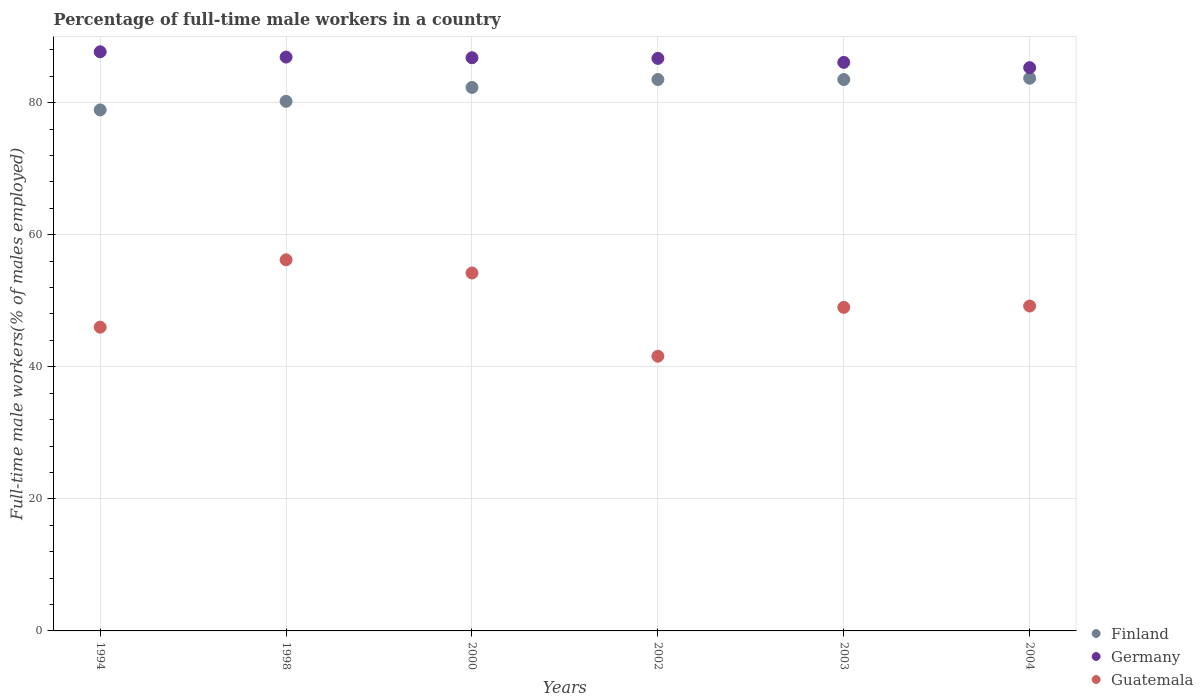How many different coloured dotlines are there?
Give a very brief answer. 3. Across all years, what is the maximum percentage of full-time male workers in Finland?
Provide a succinct answer. 83.7. Across all years, what is the minimum percentage of full-time male workers in Finland?
Offer a terse response. 78.9. In which year was the percentage of full-time male workers in Germany maximum?
Offer a terse response. 1994. In which year was the percentage of full-time male workers in Guatemala minimum?
Offer a very short reply. 2002. What is the total percentage of full-time male workers in Finland in the graph?
Make the answer very short. 492.1. What is the difference between the percentage of full-time male workers in Finland in 2003 and that in 2004?
Keep it short and to the point. -0.2. What is the difference between the percentage of full-time male workers in Finland in 2004 and the percentage of full-time male workers in Guatemala in 2000?
Offer a very short reply. 29.5. What is the average percentage of full-time male workers in Finland per year?
Provide a short and direct response. 82.02. In the year 2002, what is the difference between the percentage of full-time male workers in Guatemala and percentage of full-time male workers in Finland?
Provide a succinct answer. -41.9. What is the ratio of the percentage of full-time male workers in Guatemala in 1998 to that in 2002?
Offer a terse response. 1.35. What is the difference between the highest and the lowest percentage of full-time male workers in Germany?
Your answer should be compact. 2.4. Is it the case that in every year, the sum of the percentage of full-time male workers in Finland and percentage of full-time male workers in Guatemala  is greater than the percentage of full-time male workers in Germany?
Your answer should be compact. Yes. Does the percentage of full-time male workers in Finland monotonically increase over the years?
Provide a succinct answer. No. Is the percentage of full-time male workers in Guatemala strictly greater than the percentage of full-time male workers in Germany over the years?
Your answer should be compact. No. Is the percentage of full-time male workers in Finland strictly less than the percentage of full-time male workers in Germany over the years?
Offer a terse response. Yes. How many dotlines are there?
Make the answer very short. 3. How many years are there in the graph?
Your response must be concise. 6. Are the values on the major ticks of Y-axis written in scientific E-notation?
Offer a terse response. No. Where does the legend appear in the graph?
Give a very brief answer. Bottom right. How many legend labels are there?
Offer a very short reply. 3. How are the legend labels stacked?
Your answer should be compact. Vertical. What is the title of the graph?
Offer a terse response. Percentage of full-time male workers in a country. What is the label or title of the X-axis?
Your answer should be compact. Years. What is the label or title of the Y-axis?
Ensure brevity in your answer.  Full-time male workers(% of males employed). What is the Full-time male workers(% of males employed) in Finland in 1994?
Ensure brevity in your answer.  78.9. What is the Full-time male workers(% of males employed) in Germany in 1994?
Make the answer very short. 87.7. What is the Full-time male workers(% of males employed) in Finland in 1998?
Make the answer very short. 80.2. What is the Full-time male workers(% of males employed) in Germany in 1998?
Offer a terse response. 86.9. What is the Full-time male workers(% of males employed) of Guatemala in 1998?
Provide a short and direct response. 56.2. What is the Full-time male workers(% of males employed) in Finland in 2000?
Provide a succinct answer. 82.3. What is the Full-time male workers(% of males employed) in Germany in 2000?
Offer a terse response. 86.8. What is the Full-time male workers(% of males employed) in Guatemala in 2000?
Offer a very short reply. 54.2. What is the Full-time male workers(% of males employed) of Finland in 2002?
Your response must be concise. 83.5. What is the Full-time male workers(% of males employed) of Germany in 2002?
Make the answer very short. 86.7. What is the Full-time male workers(% of males employed) in Guatemala in 2002?
Offer a terse response. 41.6. What is the Full-time male workers(% of males employed) of Finland in 2003?
Offer a terse response. 83.5. What is the Full-time male workers(% of males employed) of Germany in 2003?
Offer a terse response. 86.1. What is the Full-time male workers(% of males employed) of Finland in 2004?
Provide a succinct answer. 83.7. What is the Full-time male workers(% of males employed) in Germany in 2004?
Your response must be concise. 85.3. What is the Full-time male workers(% of males employed) of Guatemala in 2004?
Offer a very short reply. 49.2. Across all years, what is the maximum Full-time male workers(% of males employed) in Finland?
Provide a succinct answer. 83.7. Across all years, what is the maximum Full-time male workers(% of males employed) in Germany?
Provide a succinct answer. 87.7. Across all years, what is the maximum Full-time male workers(% of males employed) in Guatemala?
Your answer should be very brief. 56.2. Across all years, what is the minimum Full-time male workers(% of males employed) in Finland?
Offer a very short reply. 78.9. Across all years, what is the minimum Full-time male workers(% of males employed) in Germany?
Make the answer very short. 85.3. Across all years, what is the minimum Full-time male workers(% of males employed) in Guatemala?
Make the answer very short. 41.6. What is the total Full-time male workers(% of males employed) of Finland in the graph?
Offer a very short reply. 492.1. What is the total Full-time male workers(% of males employed) of Germany in the graph?
Make the answer very short. 519.5. What is the total Full-time male workers(% of males employed) in Guatemala in the graph?
Provide a short and direct response. 296.2. What is the difference between the Full-time male workers(% of males employed) in Germany in 1994 and that in 2000?
Keep it short and to the point. 0.9. What is the difference between the Full-time male workers(% of males employed) in Germany in 1994 and that in 2002?
Your response must be concise. 1. What is the difference between the Full-time male workers(% of males employed) in Finland in 1994 and that in 2003?
Ensure brevity in your answer.  -4.6. What is the difference between the Full-time male workers(% of males employed) of Germany in 1994 and that in 2003?
Give a very brief answer. 1.6. What is the difference between the Full-time male workers(% of males employed) in Germany in 1994 and that in 2004?
Your answer should be compact. 2.4. What is the difference between the Full-time male workers(% of males employed) in Guatemala in 1994 and that in 2004?
Provide a short and direct response. -3.2. What is the difference between the Full-time male workers(% of males employed) in Finland in 1998 and that in 2000?
Keep it short and to the point. -2.1. What is the difference between the Full-time male workers(% of males employed) of Guatemala in 1998 and that in 2000?
Your response must be concise. 2. What is the difference between the Full-time male workers(% of males employed) in Finland in 1998 and that in 2002?
Your answer should be compact. -3.3. What is the difference between the Full-time male workers(% of males employed) of Germany in 1998 and that in 2002?
Give a very brief answer. 0.2. What is the difference between the Full-time male workers(% of males employed) in Finland in 1998 and that in 2003?
Make the answer very short. -3.3. What is the difference between the Full-time male workers(% of males employed) in Germany in 1998 and that in 2003?
Your response must be concise. 0.8. What is the difference between the Full-time male workers(% of males employed) of Guatemala in 1998 and that in 2003?
Your response must be concise. 7.2. What is the difference between the Full-time male workers(% of males employed) in Finland in 1998 and that in 2004?
Ensure brevity in your answer.  -3.5. What is the difference between the Full-time male workers(% of males employed) in Germany in 1998 and that in 2004?
Give a very brief answer. 1.6. What is the difference between the Full-time male workers(% of males employed) in Finland in 2000 and that in 2002?
Your response must be concise. -1.2. What is the difference between the Full-time male workers(% of males employed) of Finland in 2000 and that in 2003?
Ensure brevity in your answer.  -1.2. What is the difference between the Full-time male workers(% of males employed) of Guatemala in 2000 and that in 2003?
Offer a terse response. 5.2. What is the difference between the Full-time male workers(% of males employed) in Germany in 2000 and that in 2004?
Provide a succinct answer. 1.5. What is the difference between the Full-time male workers(% of males employed) of Germany in 2002 and that in 2004?
Your answer should be compact. 1.4. What is the difference between the Full-time male workers(% of males employed) in Guatemala in 2002 and that in 2004?
Ensure brevity in your answer.  -7.6. What is the difference between the Full-time male workers(% of males employed) of Germany in 2003 and that in 2004?
Provide a short and direct response. 0.8. What is the difference between the Full-time male workers(% of males employed) of Guatemala in 2003 and that in 2004?
Make the answer very short. -0.2. What is the difference between the Full-time male workers(% of males employed) in Finland in 1994 and the Full-time male workers(% of males employed) in Guatemala in 1998?
Ensure brevity in your answer.  22.7. What is the difference between the Full-time male workers(% of males employed) of Germany in 1994 and the Full-time male workers(% of males employed) of Guatemala in 1998?
Give a very brief answer. 31.5. What is the difference between the Full-time male workers(% of males employed) of Finland in 1994 and the Full-time male workers(% of males employed) of Germany in 2000?
Your answer should be compact. -7.9. What is the difference between the Full-time male workers(% of males employed) of Finland in 1994 and the Full-time male workers(% of males employed) of Guatemala in 2000?
Provide a short and direct response. 24.7. What is the difference between the Full-time male workers(% of males employed) in Germany in 1994 and the Full-time male workers(% of males employed) in Guatemala in 2000?
Provide a succinct answer. 33.5. What is the difference between the Full-time male workers(% of males employed) of Finland in 1994 and the Full-time male workers(% of males employed) of Germany in 2002?
Your answer should be very brief. -7.8. What is the difference between the Full-time male workers(% of males employed) of Finland in 1994 and the Full-time male workers(% of males employed) of Guatemala in 2002?
Ensure brevity in your answer.  37.3. What is the difference between the Full-time male workers(% of males employed) in Germany in 1994 and the Full-time male workers(% of males employed) in Guatemala in 2002?
Keep it short and to the point. 46.1. What is the difference between the Full-time male workers(% of males employed) in Finland in 1994 and the Full-time male workers(% of males employed) in Guatemala in 2003?
Your answer should be compact. 29.9. What is the difference between the Full-time male workers(% of males employed) of Germany in 1994 and the Full-time male workers(% of males employed) of Guatemala in 2003?
Provide a short and direct response. 38.7. What is the difference between the Full-time male workers(% of males employed) of Finland in 1994 and the Full-time male workers(% of males employed) of Germany in 2004?
Ensure brevity in your answer.  -6.4. What is the difference between the Full-time male workers(% of males employed) of Finland in 1994 and the Full-time male workers(% of males employed) of Guatemala in 2004?
Give a very brief answer. 29.7. What is the difference between the Full-time male workers(% of males employed) of Germany in 1994 and the Full-time male workers(% of males employed) of Guatemala in 2004?
Give a very brief answer. 38.5. What is the difference between the Full-time male workers(% of males employed) of Finland in 1998 and the Full-time male workers(% of males employed) of Germany in 2000?
Your answer should be compact. -6.6. What is the difference between the Full-time male workers(% of males employed) in Finland in 1998 and the Full-time male workers(% of males employed) in Guatemala in 2000?
Make the answer very short. 26. What is the difference between the Full-time male workers(% of males employed) in Germany in 1998 and the Full-time male workers(% of males employed) in Guatemala in 2000?
Offer a terse response. 32.7. What is the difference between the Full-time male workers(% of males employed) in Finland in 1998 and the Full-time male workers(% of males employed) in Guatemala in 2002?
Give a very brief answer. 38.6. What is the difference between the Full-time male workers(% of males employed) of Germany in 1998 and the Full-time male workers(% of males employed) of Guatemala in 2002?
Keep it short and to the point. 45.3. What is the difference between the Full-time male workers(% of males employed) in Finland in 1998 and the Full-time male workers(% of males employed) in Germany in 2003?
Your answer should be very brief. -5.9. What is the difference between the Full-time male workers(% of males employed) of Finland in 1998 and the Full-time male workers(% of males employed) of Guatemala in 2003?
Your answer should be compact. 31.2. What is the difference between the Full-time male workers(% of males employed) in Germany in 1998 and the Full-time male workers(% of males employed) in Guatemala in 2003?
Your answer should be very brief. 37.9. What is the difference between the Full-time male workers(% of males employed) of Finland in 1998 and the Full-time male workers(% of males employed) of Germany in 2004?
Provide a succinct answer. -5.1. What is the difference between the Full-time male workers(% of males employed) in Finland in 1998 and the Full-time male workers(% of males employed) in Guatemala in 2004?
Offer a very short reply. 31. What is the difference between the Full-time male workers(% of males employed) of Germany in 1998 and the Full-time male workers(% of males employed) of Guatemala in 2004?
Offer a terse response. 37.7. What is the difference between the Full-time male workers(% of males employed) in Finland in 2000 and the Full-time male workers(% of males employed) in Germany in 2002?
Offer a terse response. -4.4. What is the difference between the Full-time male workers(% of males employed) in Finland in 2000 and the Full-time male workers(% of males employed) in Guatemala in 2002?
Keep it short and to the point. 40.7. What is the difference between the Full-time male workers(% of males employed) in Germany in 2000 and the Full-time male workers(% of males employed) in Guatemala in 2002?
Keep it short and to the point. 45.2. What is the difference between the Full-time male workers(% of males employed) in Finland in 2000 and the Full-time male workers(% of males employed) in Guatemala in 2003?
Provide a succinct answer. 33.3. What is the difference between the Full-time male workers(% of males employed) in Germany in 2000 and the Full-time male workers(% of males employed) in Guatemala in 2003?
Make the answer very short. 37.8. What is the difference between the Full-time male workers(% of males employed) of Finland in 2000 and the Full-time male workers(% of males employed) of Germany in 2004?
Provide a short and direct response. -3. What is the difference between the Full-time male workers(% of males employed) of Finland in 2000 and the Full-time male workers(% of males employed) of Guatemala in 2004?
Your answer should be compact. 33.1. What is the difference between the Full-time male workers(% of males employed) in Germany in 2000 and the Full-time male workers(% of males employed) in Guatemala in 2004?
Provide a succinct answer. 37.6. What is the difference between the Full-time male workers(% of males employed) in Finland in 2002 and the Full-time male workers(% of males employed) in Guatemala in 2003?
Keep it short and to the point. 34.5. What is the difference between the Full-time male workers(% of males employed) in Germany in 2002 and the Full-time male workers(% of males employed) in Guatemala in 2003?
Ensure brevity in your answer.  37.7. What is the difference between the Full-time male workers(% of males employed) of Finland in 2002 and the Full-time male workers(% of males employed) of Germany in 2004?
Make the answer very short. -1.8. What is the difference between the Full-time male workers(% of males employed) in Finland in 2002 and the Full-time male workers(% of males employed) in Guatemala in 2004?
Your response must be concise. 34.3. What is the difference between the Full-time male workers(% of males employed) of Germany in 2002 and the Full-time male workers(% of males employed) of Guatemala in 2004?
Give a very brief answer. 37.5. What is the difference between the Full-time male workers(% of males employed) in Finland in 2003 and the Full-time male workers(% of males employed) in Germany in 2004?
Your answer should be very brief. -1.8. What is the difference between the Full-time male workers(% of males employed) in Finland in 2003 and the Full-time male workers(% of males employed) in Guatemala in 2004?
Your answer should be compact. 34.3. What is the difference between the Full-time male workers(% of males employed) of Germany in 2003 and the Full-time male workers(% of males employed) of Guatemala in 2004?
Provide a short and direct response. 36.9. What is the average Full-time male workers(% of males employed) of Finland per year?
Ensure brevity in your answer.  82.02. What is the average Full-time male workers(% of males employed) in Germany per year?
Keep it short and to the point. 86.58. What is the average Full-time male workers(% of males employed) in Guatemala per year?
Offer a very short reply. 49.37. In the year 1994, what is the difference between the Full-time male workers(% of males employed) of Finland and Full-time male workers(% of males employed) of Germany?
Give a very brief answer. -8.8. In the year 1994, what is the difference between the Full-time male workers(% of males employed) of Finland and Full-time male workers(% of males employed) of Guatemala?
Your answer should be very brief. 32.9. In the year 1994, what is the difference between the Full-time male workers(% of males employed) of Germany and Full-time male workers(% of males employed) of Guatemala?
Make the answer very short. 41.7. In the year 1998, what is the difference between the Full-time male workers(% of males employed) in Finland and Full-time male workers(% of males employed) in Germany?
Provide a succinct answer. -6.7. In the year 1998, what is the difference between the Full-time male workers(% of males employed) in Finland and Full-time male workers(% of males employed) in Guatemala?
Keep it short and to the point. 24. In the year 1998, what is the difference between the Full-time male workers(% of males employed) of Germany and Full-time male workers(% of males employed) of Guatemala?
Offer a very short reply. 30.7. In the year 2000, what is the difference between the Full-time male workers(% of males employed) of Finland and Full-time male workers(% of males employed) of Germany?
Ensure brevity in your answer.  -4.5. In the year 2000, what is the difference between the Full-time male workers(% of males employed) in Finland and Full-time male workers(% of males employed) in Guatemala?
Provide a short and direct response. 28.1. In the year 2000, what is the difference between the Full-time male workers(% of males employed) of Germany and Full-time male workers(% of males employed) of Guatemala?
Offer a terse response. 32.6. In the year 2002, what is the difference between the Full-time male workers(% of males employed) in Finland and Full-time male workers(% of males employed) in Guatemala?
Provide a short and direct response. 41.9. In the year 2002, what is the difference between the Full-time male workers(% of males employed) of Germany and Full-time male workers(% of males employed) of Guatemala?
Ensure brevity in your answer.  45.1. In the year 2003, what is the difference between the Full-time male workers(% of males employed) in Finland and Full-time male workers(% of males employed) in Germany?
Your answer should be compact. -2.6. In the year 2003, what is the difference between the Full-time male workers(% of males employed) in Finland and Full-time male workers(% of males employed) in Guatemala?
Your response must be concise. 34.5. In the year 2003, what is the difference between the Full-time male workers(% of males employed) in Germany and Full-time male workers(% of males employed) in Guatemala?
Make the answer very short. 37.1. In the year 2004, what is the difference between the Full-time male workers(% of males employed) in Finland and Full-time male workers(% of males employed) in Germany?
Your answer should be compact. -1.6. In the year 2004, what is the difference between the Full-time male workers(% of males employed) of Finland and Full-time male workers(% of males employed) of Guatemala?
Your response must be concise. 34.5. In the year 2004, what is the difference between the Full-time male workers(% of males employed) in Germany and Full-time male workers(% of males employed) in Guatemala?
Your answer should be compact. 36.1. What is the ratio of the Full-time male workers(% of males employed) in Finland in 1994 to that in 1998?
Provide a short and direct response. 0.98. What is the ratio of the Full-time male workers(% of males employed) in Germany in 1994 to that in 1998?
Your response must be concise. 1.01. What is the ratio of the Full-time male workers(% of males employed) in Guatemala in 1994 to that in 1998?
Offer a terse response. 0.82. What is the ratio of the Full-time male workers(% of males employed) of Finland in 1994 to that in 2000?
Offer a very short reply. 0.96. What is the ratio of the Full-time male workers(% of males employed) in Germany in 1994 to that in 2000?
Give a very brief answer. 1.01. What is the ratio of the Full-time male workers(% of males employed) of Guatemala in 1994 to that in 2000?
Offer a terse response. 0.85. What is the ratio of the Full-time male workers(% of males employed) in Finland in 1994 to that in 2002?
Offer a very short reply. 0.94. What is the ratio of the Full-time male workers(% of males employed) in Germany in 1994 to that in 2002?
Provide a short and direct response. 1.01. What is the ratio of the Full-time male workers(% of males employed) in Guatemala in 1994 to that in 2002?
Your answer should be compact. 1.11. What is the ratio of the Full-time male workers(% of males employed) of Finland in 1994 to that in 2003?
Give a very brief answer. 0.94. What is the ratio of the Full-time male workers(% of males employed) of Germany in 1994 to that in 2003?
Keep it short and to the point. 1.02. What is the ratio of the Full-time male workers(% of males employed) of Guatemala in 1994 to that in 2003?
Provide a short and direct response. 0.94. What is the ratio of the Full-time male workers(% of males employed) in Finland in 1994 to that in 2004?
Keep it short and to the point. 0.94. What is the ratio of the Full-time male workers(% of males employed) of Germany in 1994 to that in 2004?
Your response must be concise. 1.03. What is the ratio of the Full-time male workers(% of males employed) of Guatemala in 1994 to that in 2004?
Ensure brevity in your answer.  0.94. What is the ratio of the Full-time male workers(% of males employed) of Finland in 1998 to that in 2000?
Keep it short and to the point. 0.97. What is the ratio of the Full-time male workers(% of males employed) of Guatemala in 1998 to that in 2000?
Your answer should be compact. 1.04. What is the ratio of the Full-time male workers(% of males employed) in Finland in 1998 to that in 2002?
Provide a succinct answer. 0.96. What is the ratio of the Full-time male workers(% of males employed) of Guatemala in 1998 to that in 2002?
Give a very brief answer. 1.35. What is the ratio of the Full-time male workers(% of males employed) in Finland in 1998 to that in 2003?
Keep it short and to the point. 0.96. What is the ratio of the Full-time male workers(% of males employed) of Germany in 1998 to that in 2003?
Your response must be concise. 1.01. What is the ratio of the Full-time male workers(% of males employed) in Guatemala in 1998 to that in 2003?
Ensure brevity in your answer.  1.15. What is the ratio of the Full-time male workers(% of males employed) in Finland in 1998 to that in 2004?
Provide a short and direct response. 0.96. What is the ratio of the Full-time male workers(% of males employed) in Germany in 1998 to that in 2004?
Ensure brevity in your answer.  1.02. What is the ratio of the Full-time male workers(% of males employed) in Guatemala in 1998 to that in 2004?
Provide a short and direct response. 1.14. What is the ratio of the Full-time male workers(% of males employed) in Finland in 2000 to that in 2002?
Offer a terse response. 0.99. What is the ratio of the Full-time male workers(% of males employed) in Germany in 2000 to that in 2002?
Provide a succinct answer. 1. What is the ratio of the Full-time male workers(% of males employed) in Guatemala in 2000 to that in 2002?
Give a very brief answer. 1.3. What is the ratio of the Full-time male workers(% of males employed) of Finland in 2000 to that in 2003?
Your answer should be very brief. 0.99. What is the ratio of the Full-time male workers(% of males employed) in Guatemala in 2000 to that in 2003?
Give a very brief answer. 1.11. What is the ratio of the Full-time male workers(% of males employed) of Finland in 2000 to that in 2004?
Ensure brevity in your answer.  0.98. What is the ratio of the Full-time male workers(% of males employed) of Germany in 2000 to that in 2004?
Make the answer very short. 1.02. What is the ratio of the Full-time male workers(% of males employed) of Guatemala in 2000 to that in 2004?
Your answer should be compact. 1.1. What is the ratio of the Full-time male workers(% of males employed) in Finland in 2002 to that in 2003?
Keep it short and to the point. 1. What is the ratio of the Full-time male workers(% of males employed) in Guatemala in 2002 to that in 2003?
Offer a very short reply. 0.85. What is the ratio of the Full-time male workers(% of males employed) in Germany in 2002 to that in 2004?
Your response must be concise. 1.02. What is the ratio of the Full-time male workers(% of males employed) in Guatemala in 2002 to that in 2004?
Your response must be concise. 0.85. What is the ratio of the Full-time male workers(% of males employed) in Finland in 2003 to that in 2004?
Give a very brief answer. 1. What is the ratio of the Full-time male workers(% of males employed) in Germany in 2003 to that in 2004?
Your answer should be compact. 1.01. What is the ratio of the Full-time male workers(% of males employed) of Guatemala in 2003 to that in 2004?
Offer a very short reply. 1. What is the difference between the highest and the second highest Full-time male workers(% of males employed) of Finland?
Your answer should be compact. 0.2. What is the difference between the highest and the lowest Full-time male workers(% of males employed) in Finland?
Your answer should be compact. 4.8. What is the difference between the highest and the lowest Full-time male workers(% of males employed) in Guatemala?
Give a very brief answer. 14.6. 